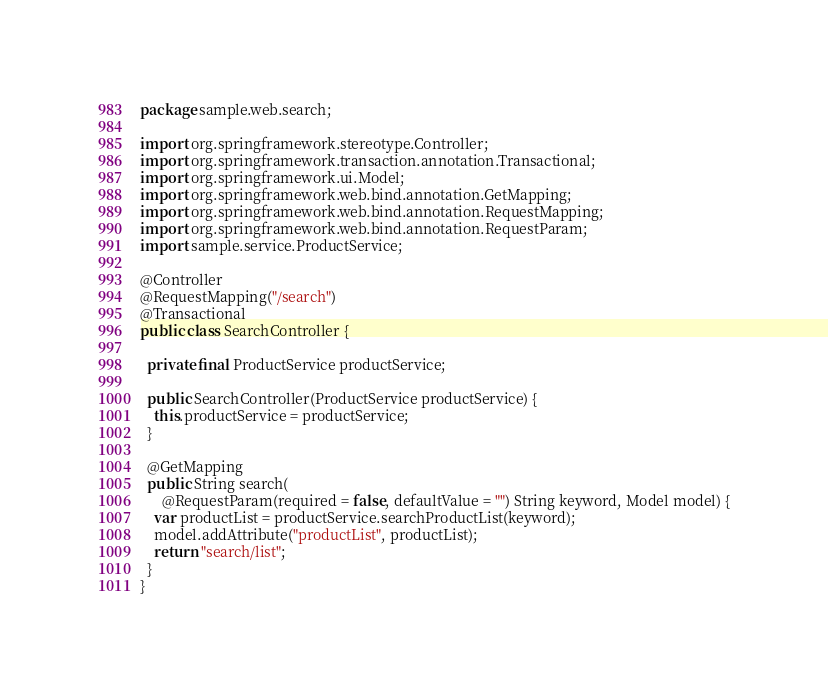<code> <loc_0><loc_0><loc_500><loc_500><_Java_>package sample.web.search;

import org.springframework.stereotype.Controller;
import org.springframework.transaction.annotation.Transactional;
import org.springframework.ui.Model;
import org.springframework.web.bind.annotation.GetMapping;
import org.springframework.web.bind.annotation.RequestMapping;
import org.springframework.web.bind.annotation.RequestParam;
import sample.service.ProductService;

@Controller
@RequestMapping("/search")
@Transactional
public class SearchController {

  private final ProductService productService;

  public SearchController(ProductService productService) {
    this.productService = productService;
  }

  @GetMapping
  public String search(
      @RequestParam(required = false, defaultValue = "") String keyword, Model model) {
    var productList = productService.searchProductList(keyword);
    model.addAttribute("productList", productList);
    return "search/list";
  }
}
</code> 